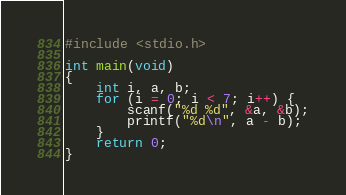<code> <loc_0><loc_0><loc_500><loc_500><_C_>#include <stdio.h>

int main(void)
{
	int i, a, b;
	for (i = 0; i < 7; i++) {
		scanf("%d %d", &a, &b);
		printf("%d\n", a - b);
	}
	return 0;
}</code> 